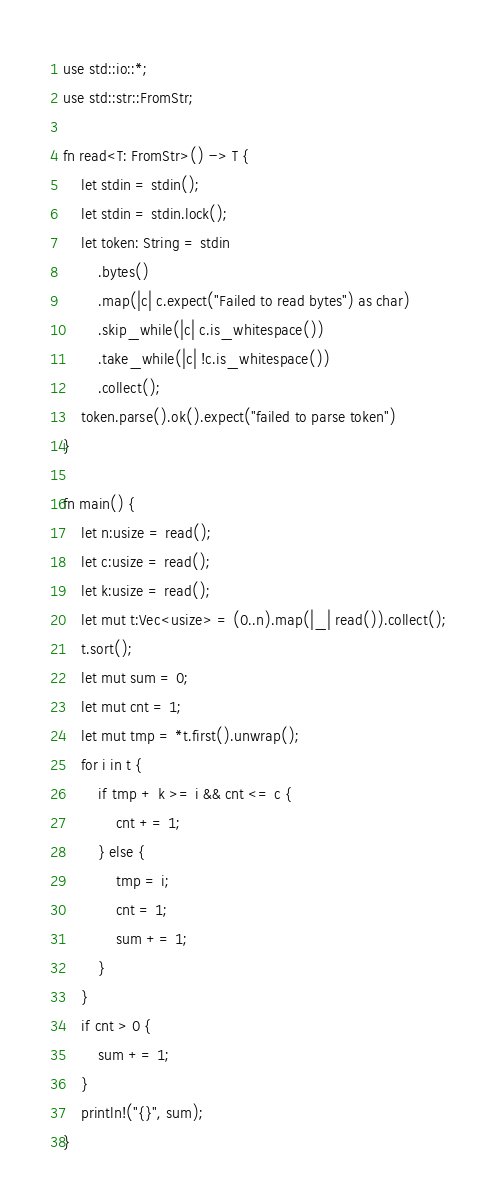<code> <loc_0><loc_0><loc_500><loc_500><_Rust_>use std::io::*;
use std::str::FromStr;

fn read<T: FromStr>() -> T {
    let stdin = stdin();
    let stdin = stdin.lock();
    let token: String = stdin
        .bytes()
        .map(|c| c.expect("Failed to read bytes") as char)
        .skip_while(|c| c.is_whitespace())
        .take_while(|c| !c.is_whitespace())
        .collect();
    token.parse().ok().expect("failed to parse token")
}

fn main() {
    let n:usize = read();
    let c:usize = read();
    let k:usize = read();
    let mut t:Vec<usize> = (0..n).map(|_| read()).collect();
    t.sort();
    let mut sum = 0;
    let mut cnt = 1;
    let mut tmp = *t.first().unwrap();
    for i in t {
        if tmp + k >= i && cnt <= c {
            cnt += 1;
        } else {
            tmp = i;
            cnt = 1;
            sum += 1;
        }
    }
    if cnt > 0 {
        sum += 1;
    }
    println!("{}", sum);
}</code> 